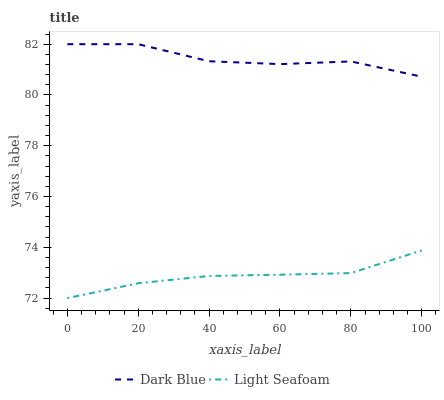Does Light Seafoam have the minimum area under the curve?
Answer yes or no. Yes. Does Dark Blue have the maximum area under the curve?
Answer yes or no. Yes. Does Light Seafoam have the maximum area under the curve?
Answer yes or no. No. Is Light Seafoam the smoothest?
Answer yes or no. Yes. Is Dark Blue the roughest?
Answer yes or no. Yes. Is Light Seafoam the roughest?
Answer yes or no. No. Does Light Seafoam have the lowest value?
Answer yes or no. Yes. Does Dark Blue have the highest value?
Answer yes or no. Yes. Does Light Seafoam have the highest value?
Answer yes or no. No. Is Light Seafoam less than Dark Blue?
Answer yes or no. Yes. Is Dark Blue greater than Light Seafoam?
Answer yes or no. Yes. Does Light Seafoam intersect Dark Blue?
Answer yes or no. No. 